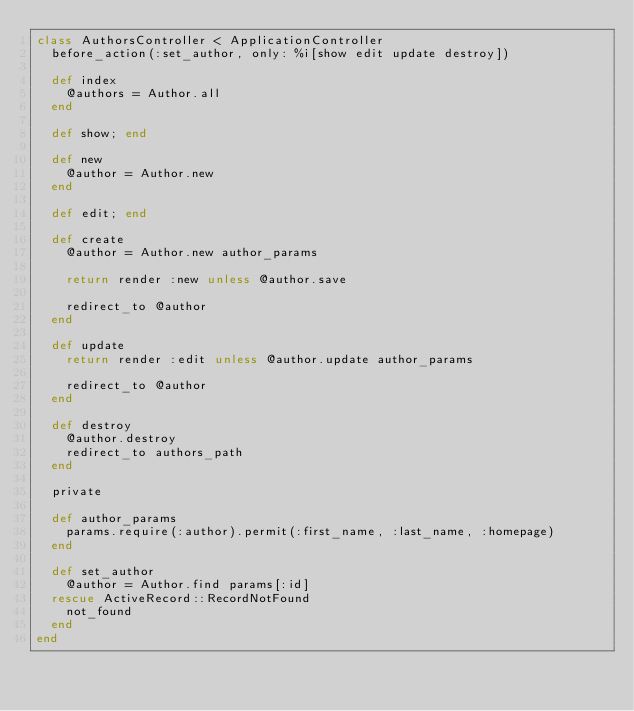<code> <loc_0><loc_0><loc_500><loc_500><_Ruby_>class AuthorsController < ApplicationController
  before_action(:set_author, only: %i[show edit update destroy])

  def index
    @authors = Author.all
  end

  def show; end

  def new
    @author = Author.new
  end

  def edit; end

  def create
    @author = Author.new author_params

    return render :new unless @author.save

    redirect_to @author
  end

  def update
    return render :edit unless @author.update author_params

    redirect_to @author
  end

  def destroy
    @author.destroy
    redirect_to authors_path
  end

  private

  def author_params
    params.require(:author).permit(:first_name, :last_name, :homepage)
  end

  def set_author
    @author = Author.find params[:id]
  rescue ActiveRecord::RecordNotFound
    not_found
  end
end
</code> 